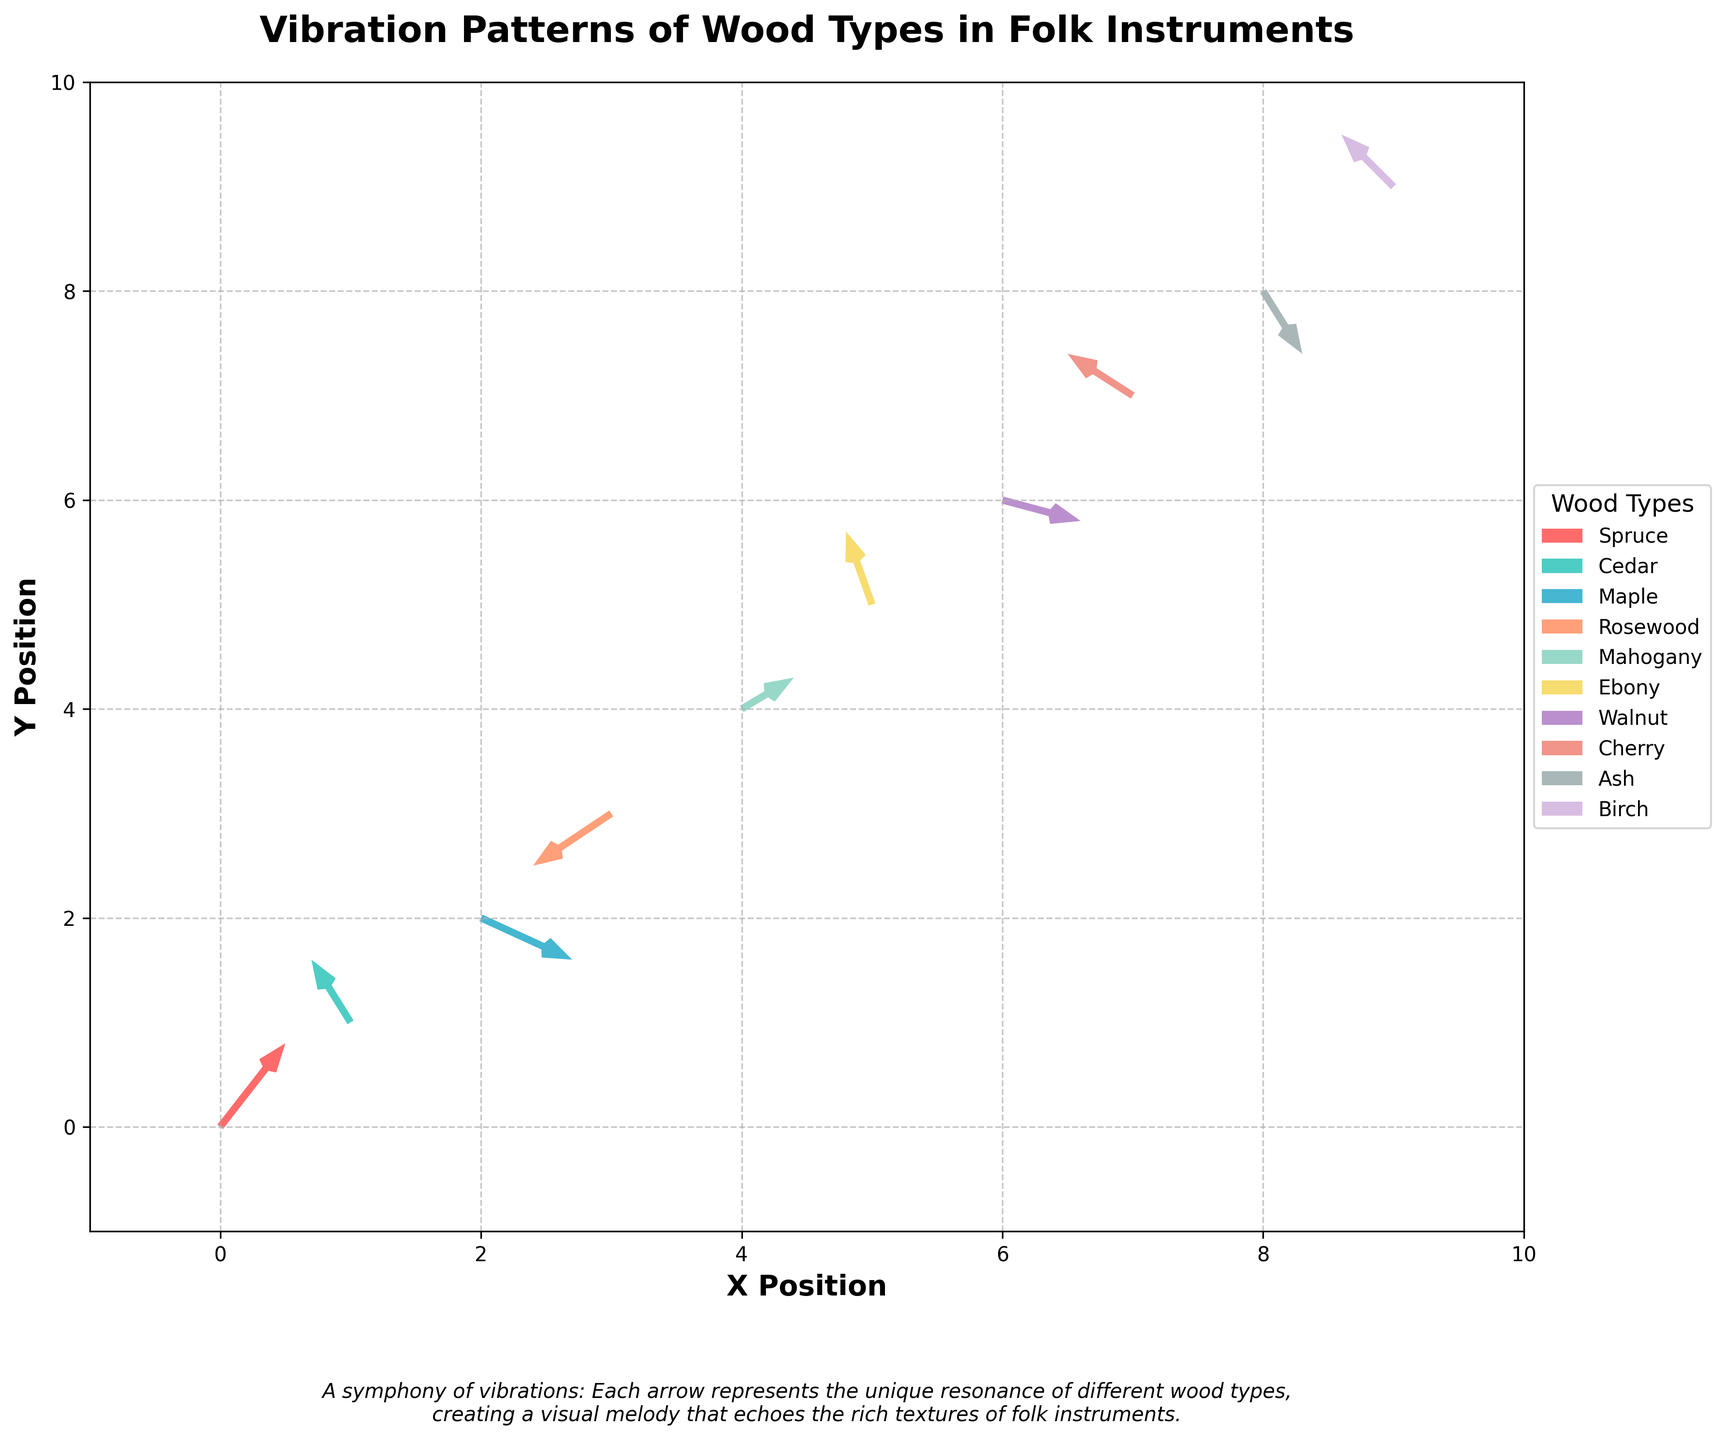What wood type has the arrow with the steepest upward direction? To identify the steepest upward direction, we need to find the arrow with the highest 'v' component. Here, the highest 'v' component is 0.8 for Spruce.
Answer: Spruce Which wood type shows the most significant downward vibration pattern? The most significant downward vibration pattern would have the most negative 'v' component. Maple has the 'v' value of -0.4 which is the most negative.
Answer: Maple What are the x and y positions for the Cedar data point? By checking the figure, Cedar data point is at position (1, 1).
Answer: (1, 1) Among all the wood types, which one has the vector closest to pointing horizontally to the right? The vector with the highest positive 'u' component and smallest 'v' component represents horizontal right movement. Walnut has 'u' = 0.6 and 'v' = -0.2, fulfilling these criteria.
Answer: Walnut Compare the vibration directions of Mahogany and Ebony. Which one moves more vertically upwards? Comparing their 'v' components, Mahogany has 'v' = 0.3 while Ebony has 'v' = 0.7. Ebony moves more vertically upwards due to the higher 'v' value.
Answer: Ebony Which wood type exhibits movement in both negative x and positive y directions? We need to find a wood type with negative 'u' and positive 'v'. Cedar has 'u' = -0.3 and 'v' = 0.6, meeting this criterion.
Answer: Cedar What wood type corresponds to the data point at (9, 9)? The data point at (9, 9) corresponds to Birch.
Answer: Birch What is the average horizontal component ('u') value for all the wood types? To find the average 'u', sum all 'u' values: 0.5+(-0.3)+0.7+(-0.6)+0.4+(-0.2)+0.6+(-0.5)+0.3+(-0.4) = 0.5. The average is 0.5 / 10 = 0.05.
Answer: 0.05 How many wood types show a negative vertical component ('v')? Count the wood types with negative 'v' values: Maple (-0.4), Rosewood (-0.5), Walnut (-0.2), Cherry (-0.6), Ash (-0.6), totaling 5.
Answer: 5 What is the range of 'v' values for all data points? The range of 'v' is calculated by subtracting the smallest value from the largest. The smallest 'v' is -0.6 and the largest 'v' is 0.8. The range is 0.8 - (-0.6) = 1.4.
Answer: 1.4 